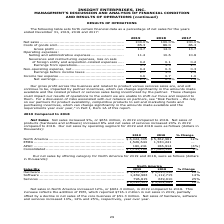According to Insight Enterprises's financial document, How much did the Net sales in North America increased in 2019 compared to 2018? According to the financial document, $661.3 million. The relevant text states: "Net sales in North America increased 12%, or $661.3 million, in 2019 compared to 2018. This increase reflects the addition of PCM, which reported $716.1 millio..." Also, What is the net sales of software in 2019 and 2018 respectively? The document shows two values: 1,269,983 and 1,112,715 (in thousands). From the document: "................................................. 1,269,983 1,112,715 14% Services ......................................................................" Also, What is the net sales of hardware in 2019 and 2018 respectively? The document shows two values: $3,957,507 and $3,610,356 (in thousands). From the document: "............................................... $ 3,957,507 $ 3,610,356 10% Software ...................................................................." Also, can you calculate: What is the change in Sales Mix of Hardware betweeen 2018 and 2019? Based on the calculation: 3,957,507-3,610,356, the result is 347151 (in thousands). This is based on the information: "................................... $ 3,957,507 $ 3,610,356 10% Software .................................................................... 1,269,983 1,112,7 ..........................................." The key data points involved are: 3,610,356, 3,957,507. Also, can you calculate: What is the change in Sales Mix of Software between 2018 and 2019? Based on the calculation: 1,269,983-1,112,715, the result is 157268 (in thousands). This is based on the information: "................................................. 1,269,983 1,112,715 14% Services ..................................................................... 796,81 ....................................... ..." The key data points involved are: 1,112,715, 1,269,983. Also, can you calculate: What is the average Sales Mix of Hardware for 2018 and 2019? To answer this question, I need to perform calculations using the financial data. The calculation is: (3,957,507+3,610,356) / 2, which equals 3783931.5 (in thousands). This is based on the information: "................................... $ 3,957,507 $ 3,610,356 10% Software .................................................................... 1,269,983 1,112,7 ..........................................." The key data points involved are: 3,610,356, 3,957,507. 